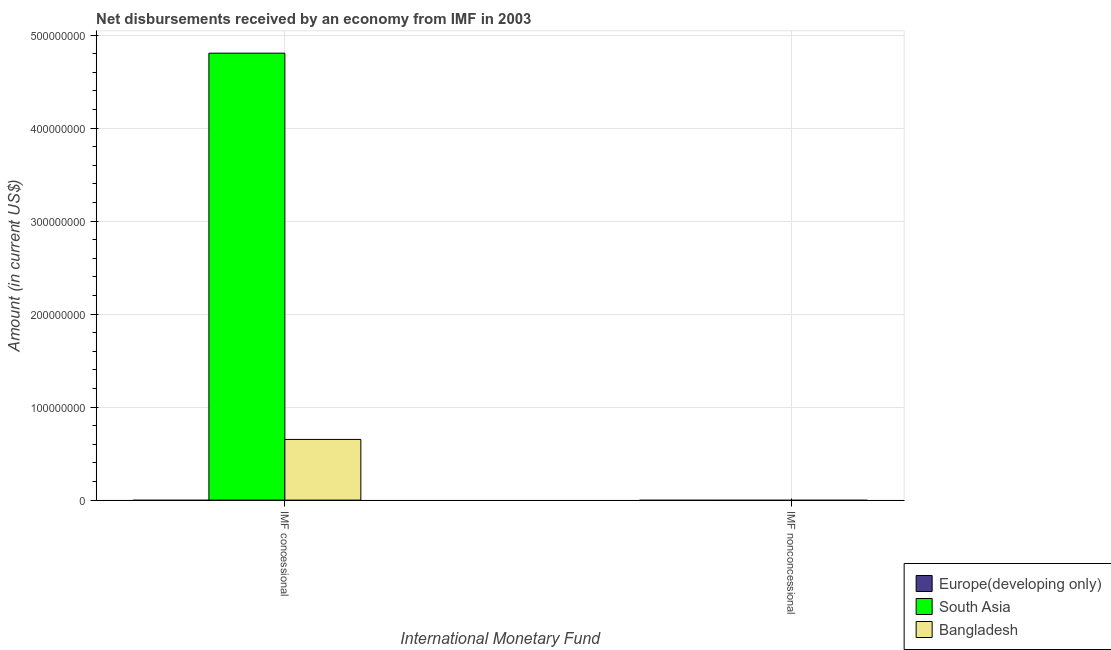Are the number of bars per tick equal to the number of legend labels?
Your response must be concise. No. How many bars are there on the 2nd tick from the right?
Your response must be concise. 2. What is the label of the 1st group of bars from the left?
Your response must be concise. IMF concessional. What is the net concessional disbursements from imf in Bangladesh?
Your answer should be very brief. 6.52e+07. Across all countries, what is the maximum net concessional disbursements from imf?
Offer a terse response. 4.80e+08. Across all countries, what is the minimum net non concessional disbursements from imf?
Your answer should be very brief. 0. What is the total net concessional disbursements from imf in the graph?
Make the answer very short. 5.46e+08. What is the difference between the net concessional disbursements from imf in South Asia and that in Bangladesh?
Your response must be concise. 4.15e+08. What is the difference between the net concessional disbursements from imf in Bangladesh and the net non concessional disbursements from imf in South Asia?
Your answer should be compact. 6.52e+07. What is the average net concessional disbursements from imf per country?
Your answer should be compact. 1.82e+08. In how many countries, is the net concessional disbursements from imf greater than 200000000 US$?
Your answer should be compact. 1. What is the ratio of the net concessional disbursements from imf in South Asia to that in Bangladesh?
Offer a terse response. 7.37. In how many countries, is the net non concessional disbursements from imf greater than the average net non concessional disbursements from imf taken over all countries?
Your answer should be compact. 0. How many bars are there?
Ensure brevity in your answer.  2. Are all the bars in the graph horizontal?
Your response must be concise. No. What is the difference between two consecutive major ticks on the Y-axis?
Ensure brevity in your answer.  1.00e+08. Does the graph contain grids?
Give a very brief answer. Yes. Where does the legend appear in the graph?
Your answer should be compact. Bottom right. How many legend labels are there?
Ensure brevity in your answer.  3. What is the title of the graph?
Offer a terse response. Net disbursements received by an economy from IMF in 2003. What is the label or title of the X-axis?
Offer a terse response. International Monetary Fund. What is the label or title of the Y-axis?
Make the answer very short. Amount (in current US$). What is the Amount (in current US$) in Europe(developing only) in IMF concessional?
Keep it short and to the point. 0. What is the Amount (in current US$) of South Asia in IMF concessional?
Give a very brief answer. 4.80e+08. What is the Amount (in current US$) of Bangladesh in IMF concessional?
Provide a short and direct response. 6.52e+07. Across all International Monetary Fund, what is the maximum Amount (in current US$) in South Asia?
Offer a very short reply. 4.80e+08. Across all International Monetary Fund, what is the maximum Amount (in current US$) of Bangladesh?
Offer a very short reply. 6.52e+07. Across all International Monetary Fund, what is the minimum Amount (in current US$) of South Asia?
Make the answer very short. 0. Across all International Monetary Fund, what is the minimum Amount (in current US$) of Bangladesh?
Your answer should be compact. 0. What is the total Amount (in current US$) in South Asia in the graph?
Your answer should be compact. 4.80e+08. What is the total Amount (in current US$) in Bangladesh in the graph?
Keep it short and to the point. 6.52e+07. What is the average Amount (in current US$) in South Asia per International Monetary Fund?
Make the answer very short. 2.40e+08. What is the average Amount (in current US$) of Bangladesh per International Monetary Fund?
Give a very brief answer. 3.26e+07. What is the difference between the Amount (in current US$) in South Asia and Amount (in current US$) in Bangladesh in IMF concessional?
Your answer should be very brief. 4.15e+08. What is the difference between the highest and the lowest Amount (in current US$) of South Asia?
Your answer should be very brief. 4.80e+08. What is the difference between the highest and the lowest Amount (in current US$) in Bangladesh?
Keep it short and to the point. 6.52e+07. 